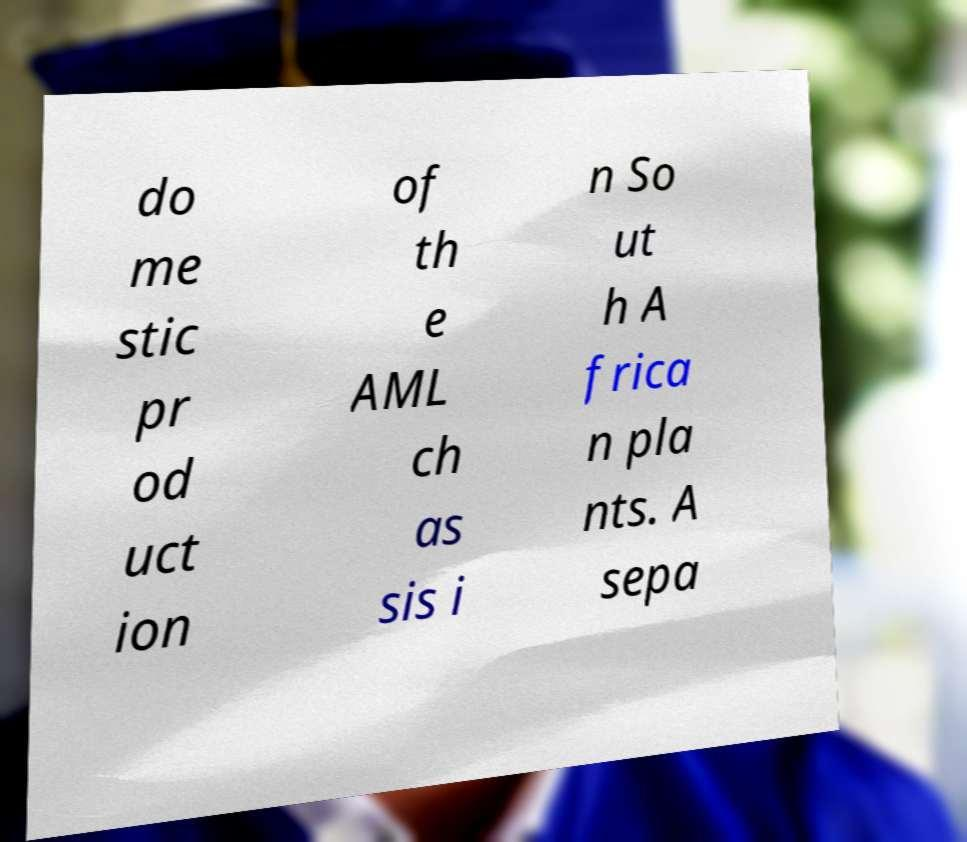Can you accurately transcribe the text from the provided image for me? do me stic pr od uct ion of th e AML ch as sis i n So ut h A frica n pla nts. A sepa 